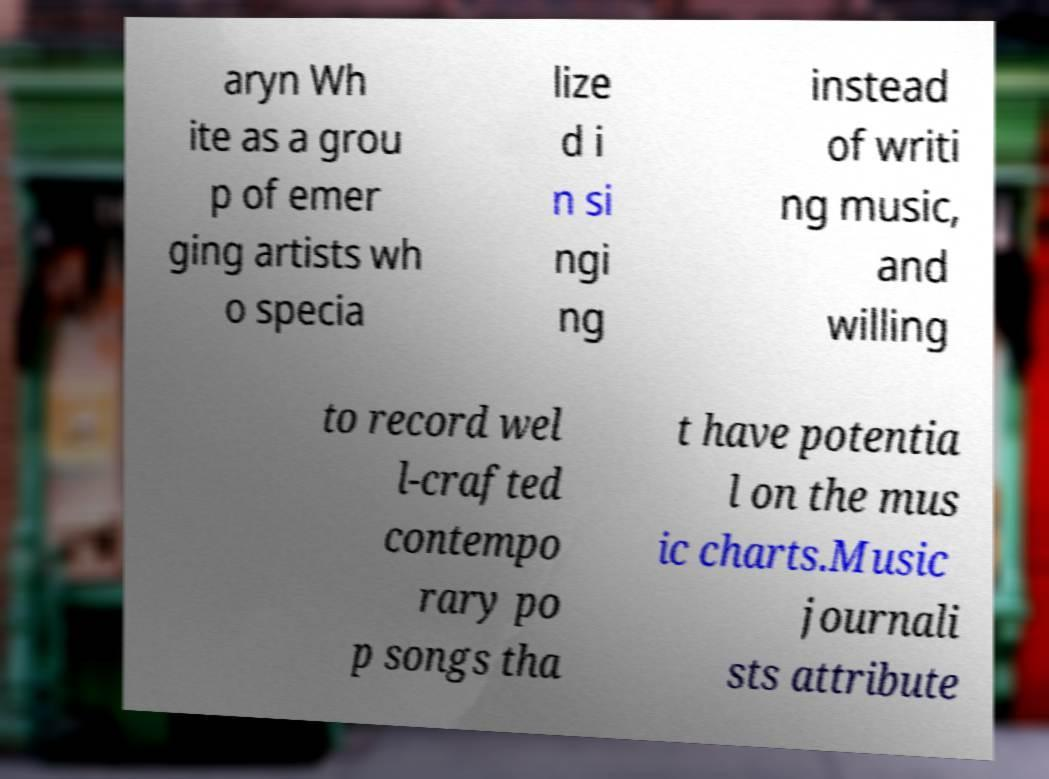Could you assist in decoding the text presented in this image and type it out clearly? aryn Wh ite as a grou p of emer ging artists wh o specia lize d i n si ngi ng instead of writi ng music, and willing to record wel l-crafted contempo rary po p songs tha t have potentia l on the mus ic charts.Music journali sts attribute 